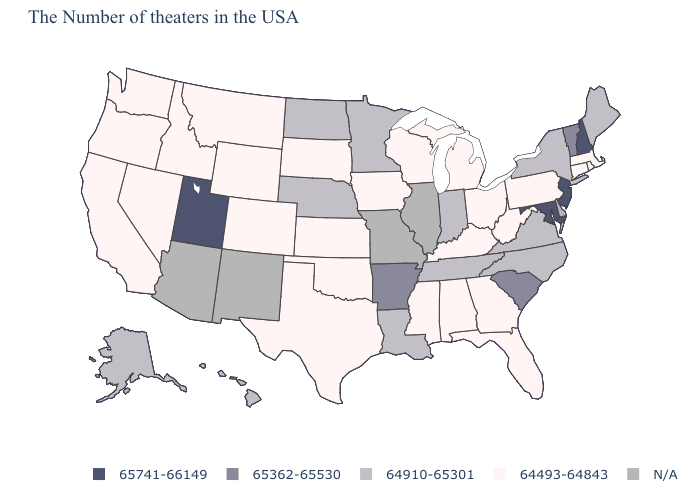Does Nebraska have the lowest value in the USA?
Be succinct. No. Name the states that have a value in the range 65741-66149?
Give a very brief answer. New Hampshire, New Jersey, Maryland, Utah. Is the legend a continuous bar?
Be succinct. No. Does the map have missing data?
Concise answer only. Yes. Does the map have missing data?
Short answer required. Yes. Which states have the lowest value in the USA?
Concise answer only. Massachusetts, Rhode Island, Connecticut, Pennsylvania, West Virginia, Ohio, Florida, Georgia, Michigan, Kentucky, Alabama, Wisconsin, Mississippi, Iowa, Kansas, Oklahoma, Texas, South Dakota, Wyoming, Colorado, Montana, Idaho, Nevada, California, Washington, Oregon. What is the lowest value in the USA?
Be succinct. 64493-64843. Name the states that have a value in the range 64910-65301?
Write a very short answer. Maine, New York, Virginia, North Carolina, Indiana, Tennessee, Louisiana, Minnesota, Nebraska, North Dakota, Alaska, Hawaii. What is the value of Mississippi?
Keep it brief. 64493-64843. What is the value of Nebraska?
Short answer required. 64910-65301. What is the value of Washington?
Quick response, please. 64493-64843. What is the value of Alaska?
Give a very brief answer. 64910-65301. What is the value of Minnesota?
Short answer required. 64910-65301. Among the states that border Illinois , which have the highest value?
Be succinct. Indiana. 